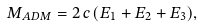Convert formula to latex. <formula><loc_0><loc_0><loc_500><loc_500>M _ { A D M } = 2 \, c \, ( E _ { 1 } + E _ { 2 } + E _ { 3 } ) ,</formula> 